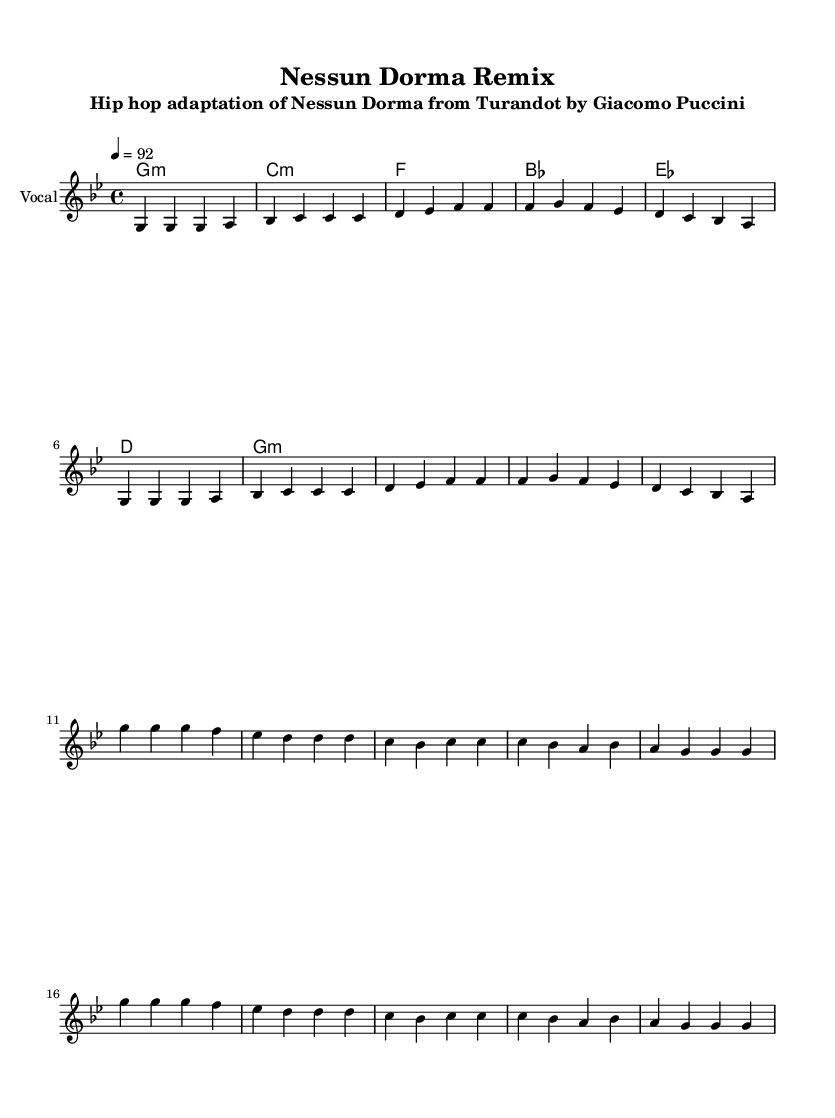What is the key signature of this music? The key signature is indicated at the beginning of the music. Here, it shows one flat, which corresponds to G minor.
Answer: G minor What is the time signature of the piece? The time signature is located at the beginning of the score, and it indicates 4/4 time, meaning there are four beats in a measure.
Answer: 4/4 What is the tempo marking for this adaptation? The tempo marking is shown above the staff, indicating how fast the music should be played. It states "4 = 92", meaning each quarter note gets a tempo of 92 beats per minute.
Answer: 92 How many measures are in the verse section? To determine the number of measures, we can count the bars in the verse section that is indicated by the note grouping. There are 8 measures listed for the verse.
Answer: 8 What is the last note of the chorus? The last note of the chorus is found in the melody section and can be identified at the end of the chord and note line. The last note is G.
Answer: G Which section contains the lyric "guar di le ste le"? By looking at the lyrics beneath the melody, we can find that this specific lyric appears in the verse section. It is located in the first half of the verse.
Answer: Verse What is the musical genre represented in this adaptation? The musical genre can be inferred from the title and subtitle of the piece, which refers to a "Hip hop adaptation". The combination of a traditional opera aria and hip hop influences showcases this genre.
Answer: Hip hop 